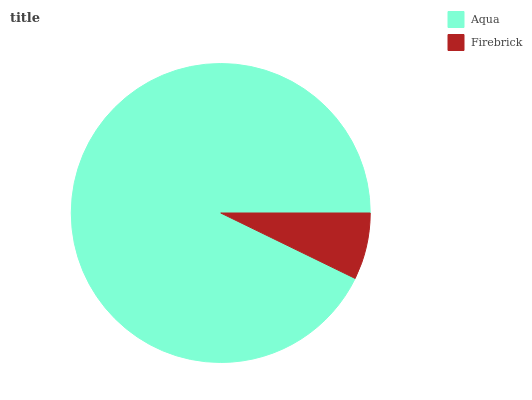Is Firebrick the minimum?
Answer yes or no. Yes. Is Aqua the maximum?
Answer yes or no. Yes. Is Firebrick the maximum?
Answer yes or no. No. Is Aqua greater than Firebrick?
Answer yes or no. Yes. Is Firebrick less than Aqua?
Answer yes or no. Yes. Is Firebrick greater than Aqua?
Answer yes or no. No. Is Aqua less than Firebrick?
Answer yes or no. No. Is Aqua the high median?
Answer yes or no. Yes. Is Firebrick the low median?
Answer yes or no. Yes. Is Firebrick the high median?
Answer yes or no. No. Is Aqua the low median?
Answer yes or no. No. 